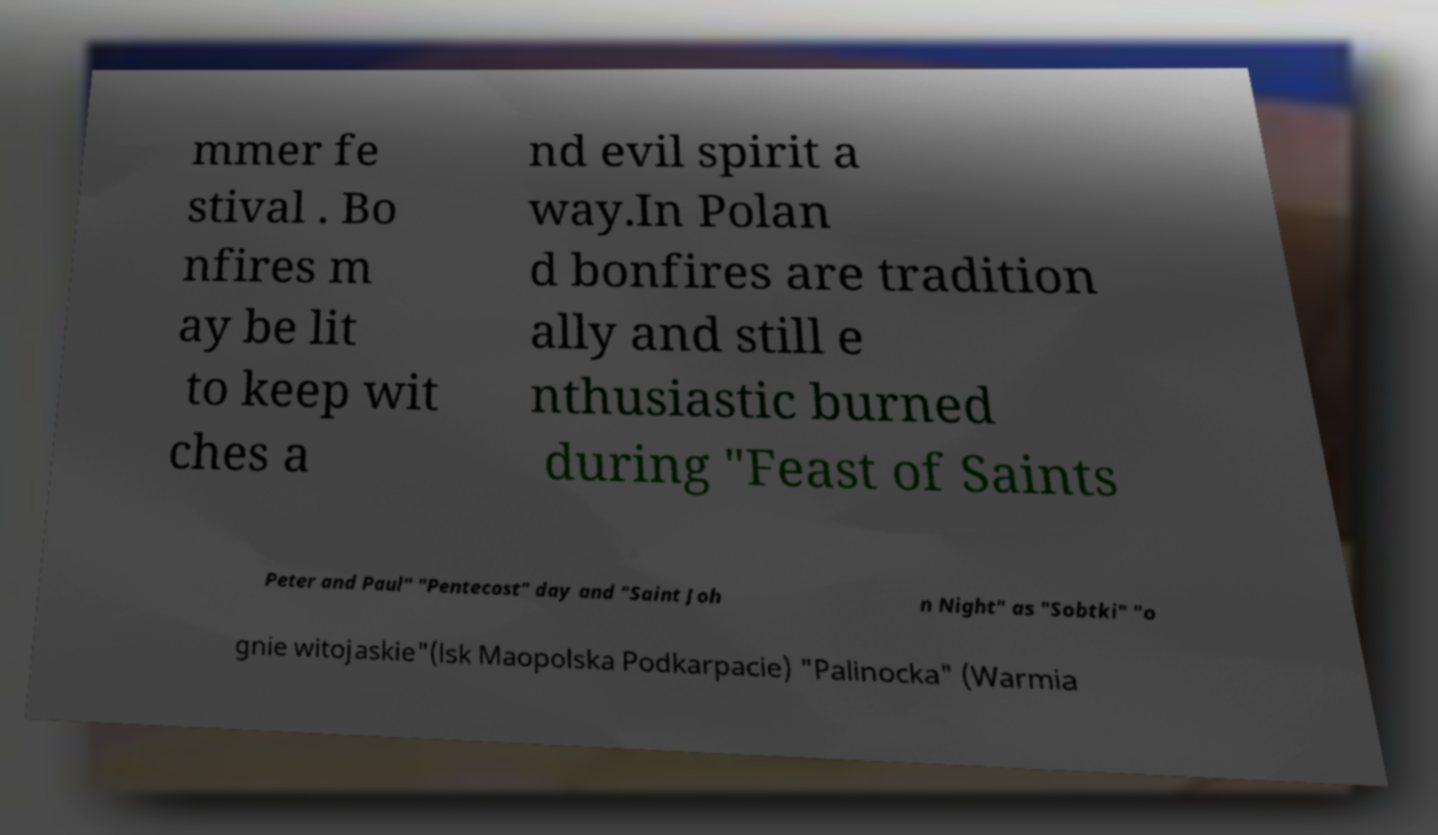Could you assist in decoding the text presented in this image and type it out clearly? mmer fe stival . Bo nfires m ay be lit to keep wit ches a nd evil spirit a way.In Polan d bonfires are tradition ally and still e nthusiastic burned during "Feast of Saints Peter and Paul" "Pentecost" day and "Saint Joh n Night" as "Sobtki" "o gnie witojaskie"(lsk Maopolska Podkarpacie) "Palinocka" (Warmia 